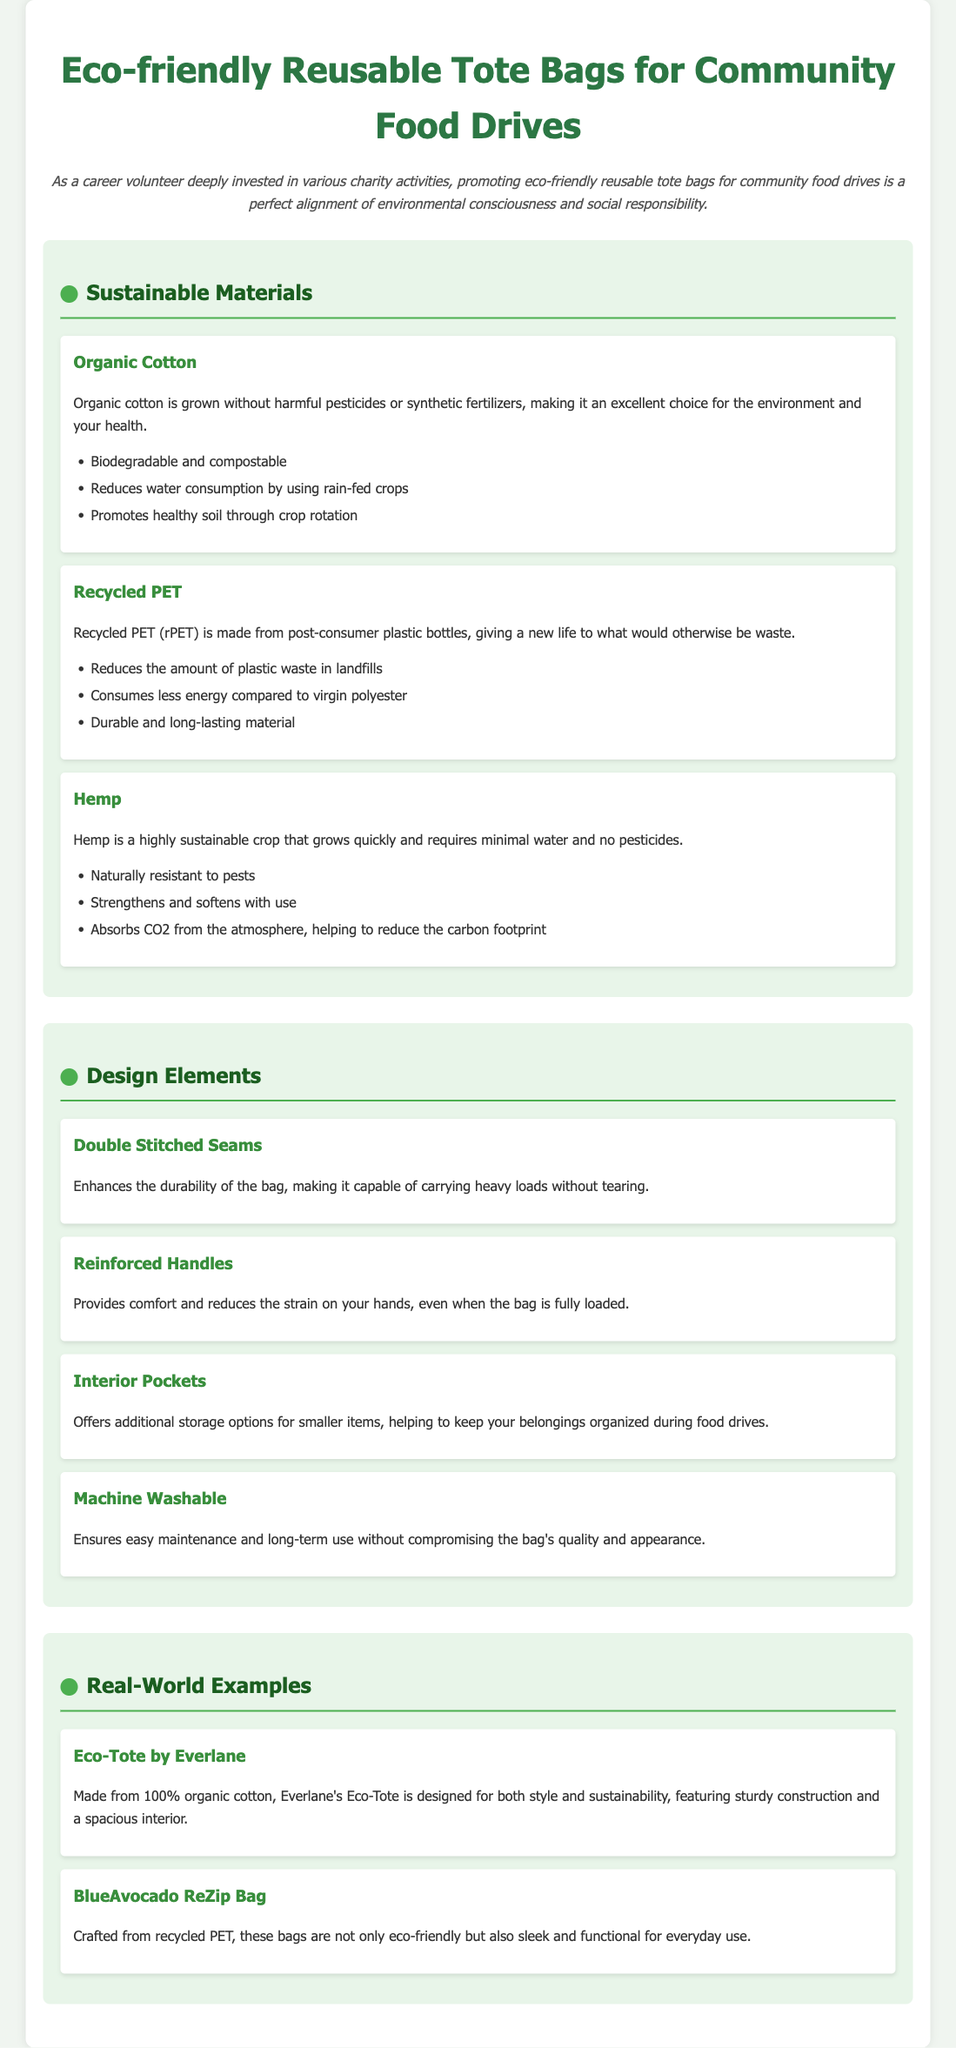what materials are used for the tote bags? The document lists three materials used for the tote bags: organic cotton, recycled PET, and hemp.
Answer: organic cotton, recycled PET, hemp what feature enhances the durability of the bag? The feature mentioned that enhances durability is double stitched seams, which makes the bag capable of carrying heavy loads.
Answer: double stitched seams which company produces the Eco-Tote? The document mentions Everlane as the company that produces the Eco-Tote made from 100% organic cotton.
Answer: Everlane how many design elements are listed in the document? The document outlines four design elements that contribute to the tote bag's functionality and user experience.
Answer: four why is organic cotton considered environmentally friendly? Organic cotton is considered environmentally friendly because it is grown without harmful pesticides or synthetic fertilizers.
Answer: without harmful pesticides or synthetic fertilizers what is the benefit of interior pockets? The benefit of interior pockets is that they offer additional storage options for smaller items, helping to keep belongings organized.
Answer: additional storage options what type of product is this document promoting? The document is promoting eco-friendly reusable tote bags specifically for community food drives.
Answer: eco-friendly reusable tote bags which material is made from post-consumer plastic bottles? The material made from post-consumer plastic bottles is recycled PET (rPET).
Answer: recycled PET (rPET) how is the hemp crop characterized in the document? The hemp crop is characterized as a highly sustainable crop that grows quickly and requires minimal water and no pesticides.
Answer: highly sustainable crop 